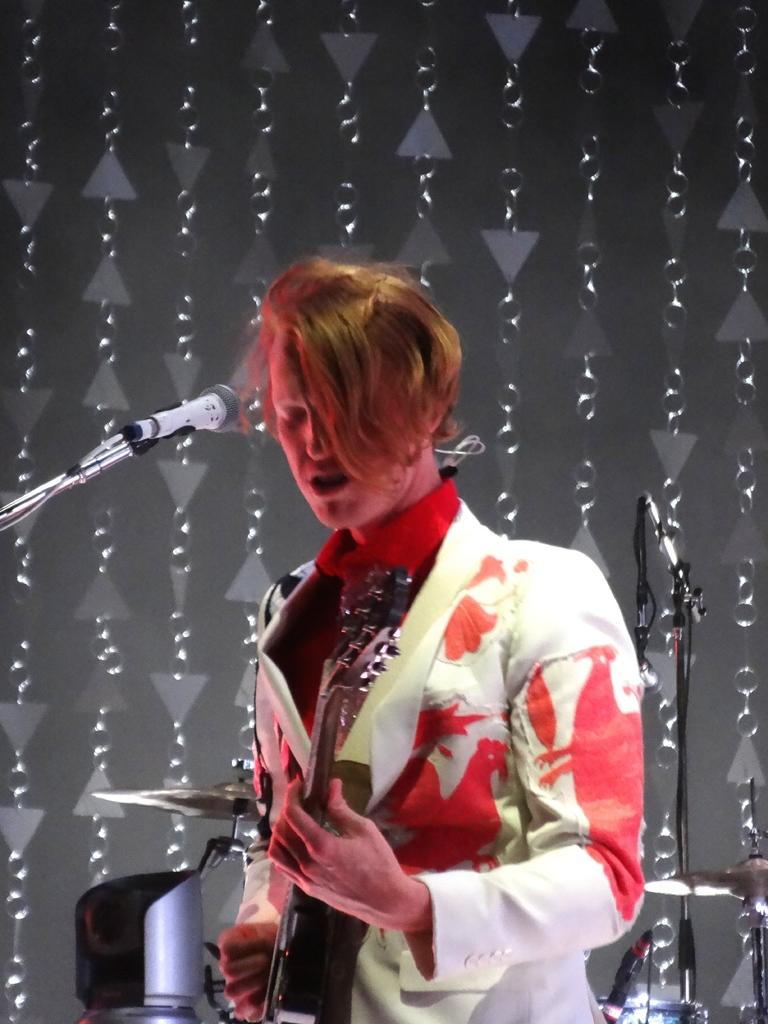What is the man in the center of the image doing? The man is standing in the center of the image and holding a guitar. What is the man doing with the guitar? The man is at a microphone, which suggests he might be singing or performing. What can be seen in the background of the image? There are musical instruments and a wall in the background. What type of corn is being used as a prop in the image? There is no corn present in the image. How does the man slip on the stage during his performance in the image? The man does not slip on the stage in the image; he is standing still while holding a guitar. 